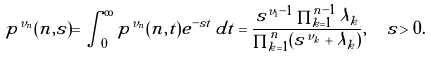<formula> <loc_0><loc_0><loc_500><loc_500>\tilde { p } ^ { \nu _ { n } } ( n , s ) = \int _ { 0 } ^ { \infty } p ^ { \nu _ { n } } ( n , t ) e ^ { - s t } \, d t = \frac { s ^ { \nu _ { 1 } - 1 } \prod _ { k = 1 } ^ { n - 1 } \lambda _ { k } } { \prod _ { k = 1 } ^ { n } ( s ^ { \nu _ { k } } + \lambda _ { k } ) } , \ \ s > 0 .</formula> 